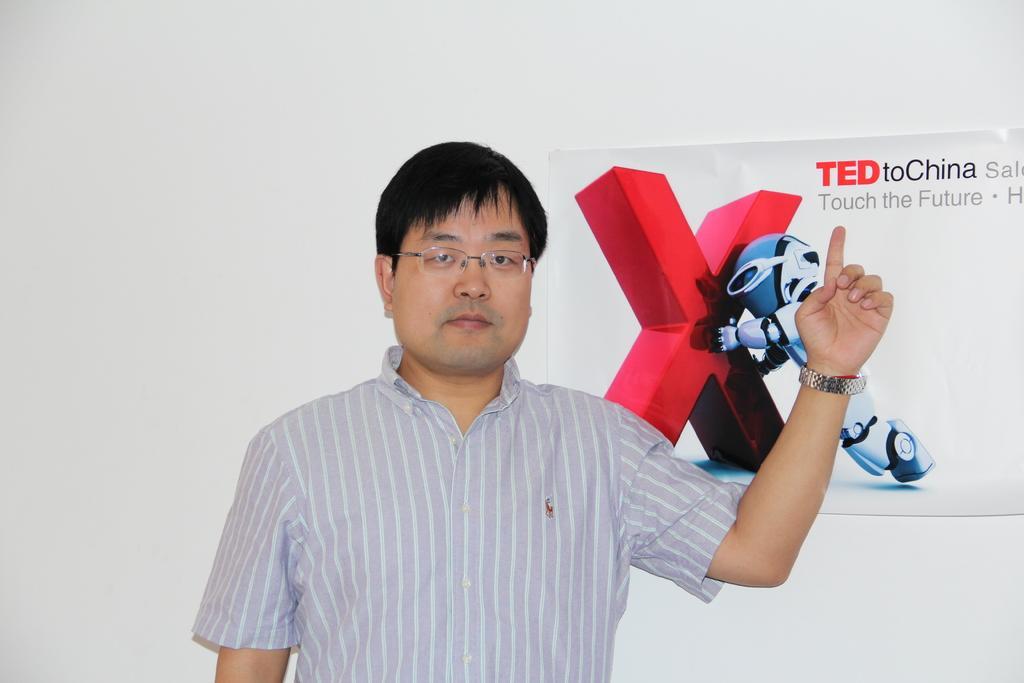In one or two sentences, can you explain what this image depicts? In this picture we can see a person and in the background we can see a poster on the wall. 